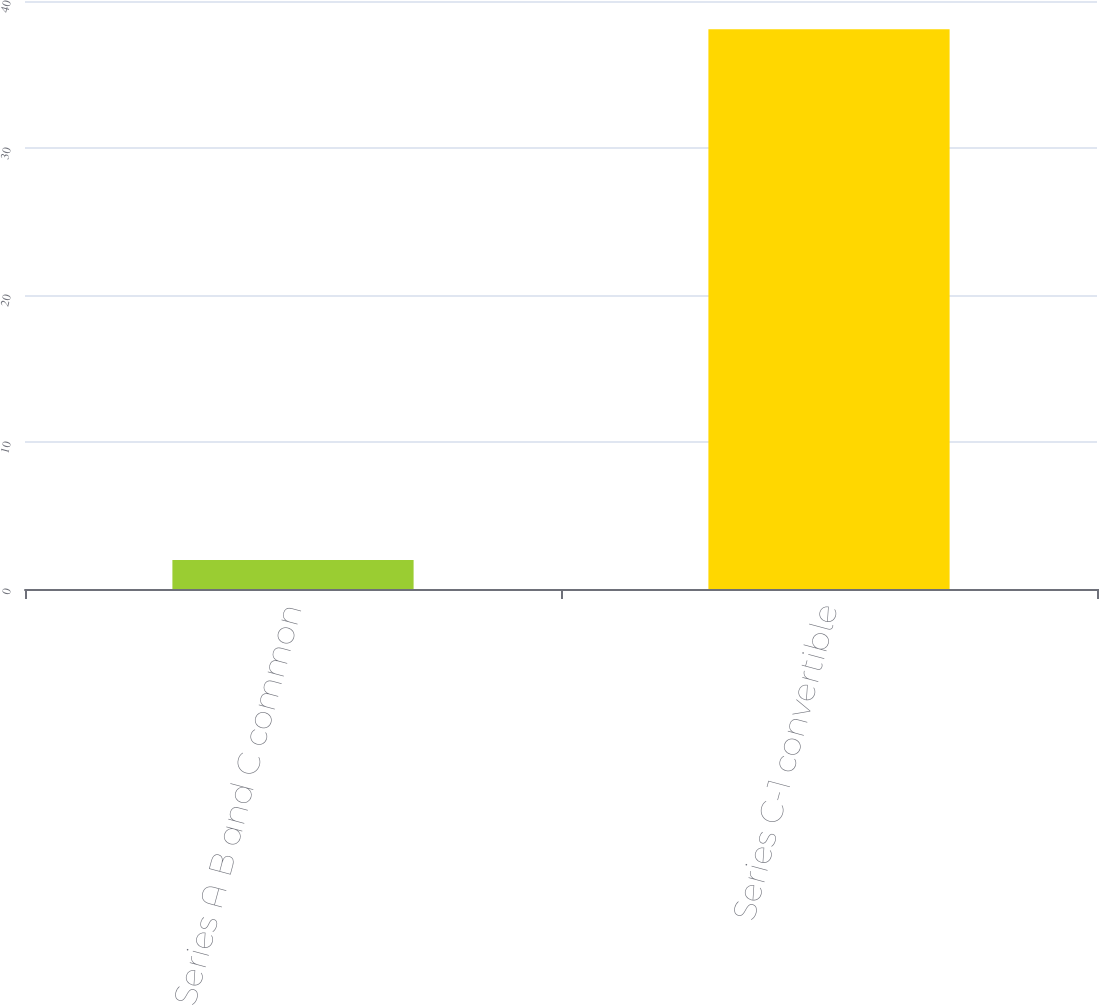Convert chart. <chart><loc_0><loc_0><loc_500><loc_500><bar_chart><fcel>Series A B and C common<fcel>Series C-1 convertible<nl><fcel>1.97<fcel>38.07<nl></chart> 